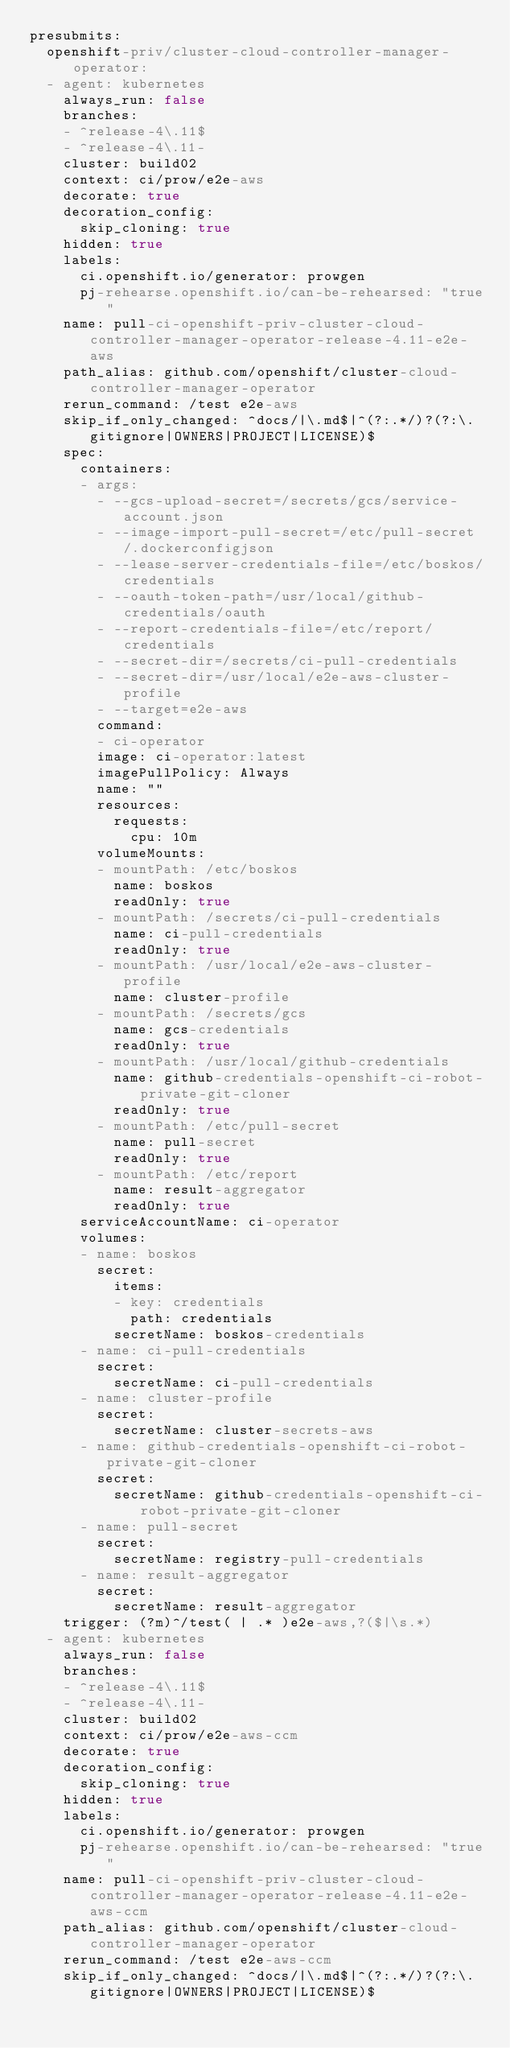<code> <loc_0><loc_0><loc_500><loc_500><_YAML_>presubmits:
  openshift-priv/cluster-cloud-controller-manager-operator:
  - agent: kubernetes
    always_run: false
    branches:
    - ^release-4\.11$
    - ^release-4\.11-
    cluster: build02
    context: ci/prow/e2e-aws
    decorate: true
    decoration_config:
      skip_cloning: true
    hidden: true
    labels:
      ci.openshift.io/generator: prowgen
      pj-rehearse.openshift.io/can-be-rehearsed: "true"
    name: pull-ci-openshift-priv-cluster-cloud-controller-manager-operator-release-4.11-e2e-aws
    path_alias: github.com/openshift/cluster-cloud-controller-manager-operator
    rerun_command: /test e2e-aws
    skip_if_only_changed: ^docs/|\.md$|^(?:.*/)?(?:\.gitignore|OWNERS|PROJECT|LICENSE)$
    spec:
      containers:
      - args:
        - --gcs-upload-secret=/secrets/gcs/service-account.json
        - --image-import-pull-secret=/etc/pull-secret/.dockerconfigjson
        - --lease-server-credentials-file=/etc/boskos/credentials
        - --oauth-token-path=/usr/local/github-credentials/oauth
        - --report-credentials-file=/etc/report/credentials
        - --secret-dir=/secrets/ci-pull-credentials
        - --secret-dir=/usr/local/e2e-aws-cluster-profile
        - --target=e2e-aws
        command:
        - ci-operator
        image: ci-operator:latest
        imagePullPolicy: Always
        name: ""
        resources:
          requests:
            cpu: 10m
        volumeMounts:
        - mountPath: /etc/boskos
          name: boskos
          readOnly: true
        - mountPath: /secrets/ci-pull-credentials
          name: ci-pull-credentials
          readOnly: true
        - mountPath: /usr/local/e2e-aws-cluster-profile
          name: cluster-profile
        - mountPath: /secrets/gcs
          name: gcs-credentials
          readOnly: true
        - mountPath: /usr/local/github-credentials
          name: github-credentials-openshift-ci-robot-private-git-cloner
          readOnly: true
        - mountPath: /etc/pull-secret
          name: pull-secret
          readOnly: true
        - mountPath: /etc/report
          name: result-aggregator
          readOnly: true
      serviceAccountName: ci-operator
      volumes:
      - name: boskos
        secret:
          items:
          - key: credentials
            path: credentials
          secretName: boskos-credentials
      - name: ci-pull-credentials
        secret:
          secretName: ci-pull-credentials
      - name: cluster-profile
        secret:
          secretName: cluster-secrets-aws
      - name: github-credentials-openshift-ci-robot-private-git-cloner
        secret:
          secretName: github-credentials-openshift-ci-robot-private-git-cloner
      - name: pull-secret
        secret:
          secretName: registry-pull-credentials
      - name: result-aggregator
        secret:
          secretName: result-aggregator
    trigger: (?m)^/test( | .* )e2e-aws,?($|\s.*)
  - agent: kubernetes
    always_run: false
    branches:
    - ^release-4\.11$
    - ^release-4\.11-
    cluster: build02
    context: ci/prow/e2e-aws-ccm
    decorate: true
    decoration_config:
      skip_cloning: true
    hidden: true
    labels:
      ci.openshift.io/generator: prowgen
      pj-rehearse.openshift.io/can-be-rehearsed: "true"
    name: pull-ci-openshift-priv-cluster-cloud-controller-manager-operator-release-4.11-e2e-aws-ccm
    path_alias: github.com/openshift/cluster-cloud-controller-manager-operator
    rerun_command: /test e2e-aws-ccm
    skip_if_only_changed: ^docs/|\.md$|^(?:.*/)?(?:\.gitignore|OWNERS|PROJECT|LICENSE)$</code> 